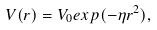<formula> <loc_0><loc_0><loc_500><loc_500>V ( r ) = V _ { 0 } e x p ( - \eta r ^ { 2 } ) ,</formula> 